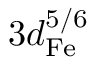Convert formula to latex. <formula><loc_0><loc_0><loc_500><loc_500>3 d _ { F e } ^ { 5 / 6 }</formula> 